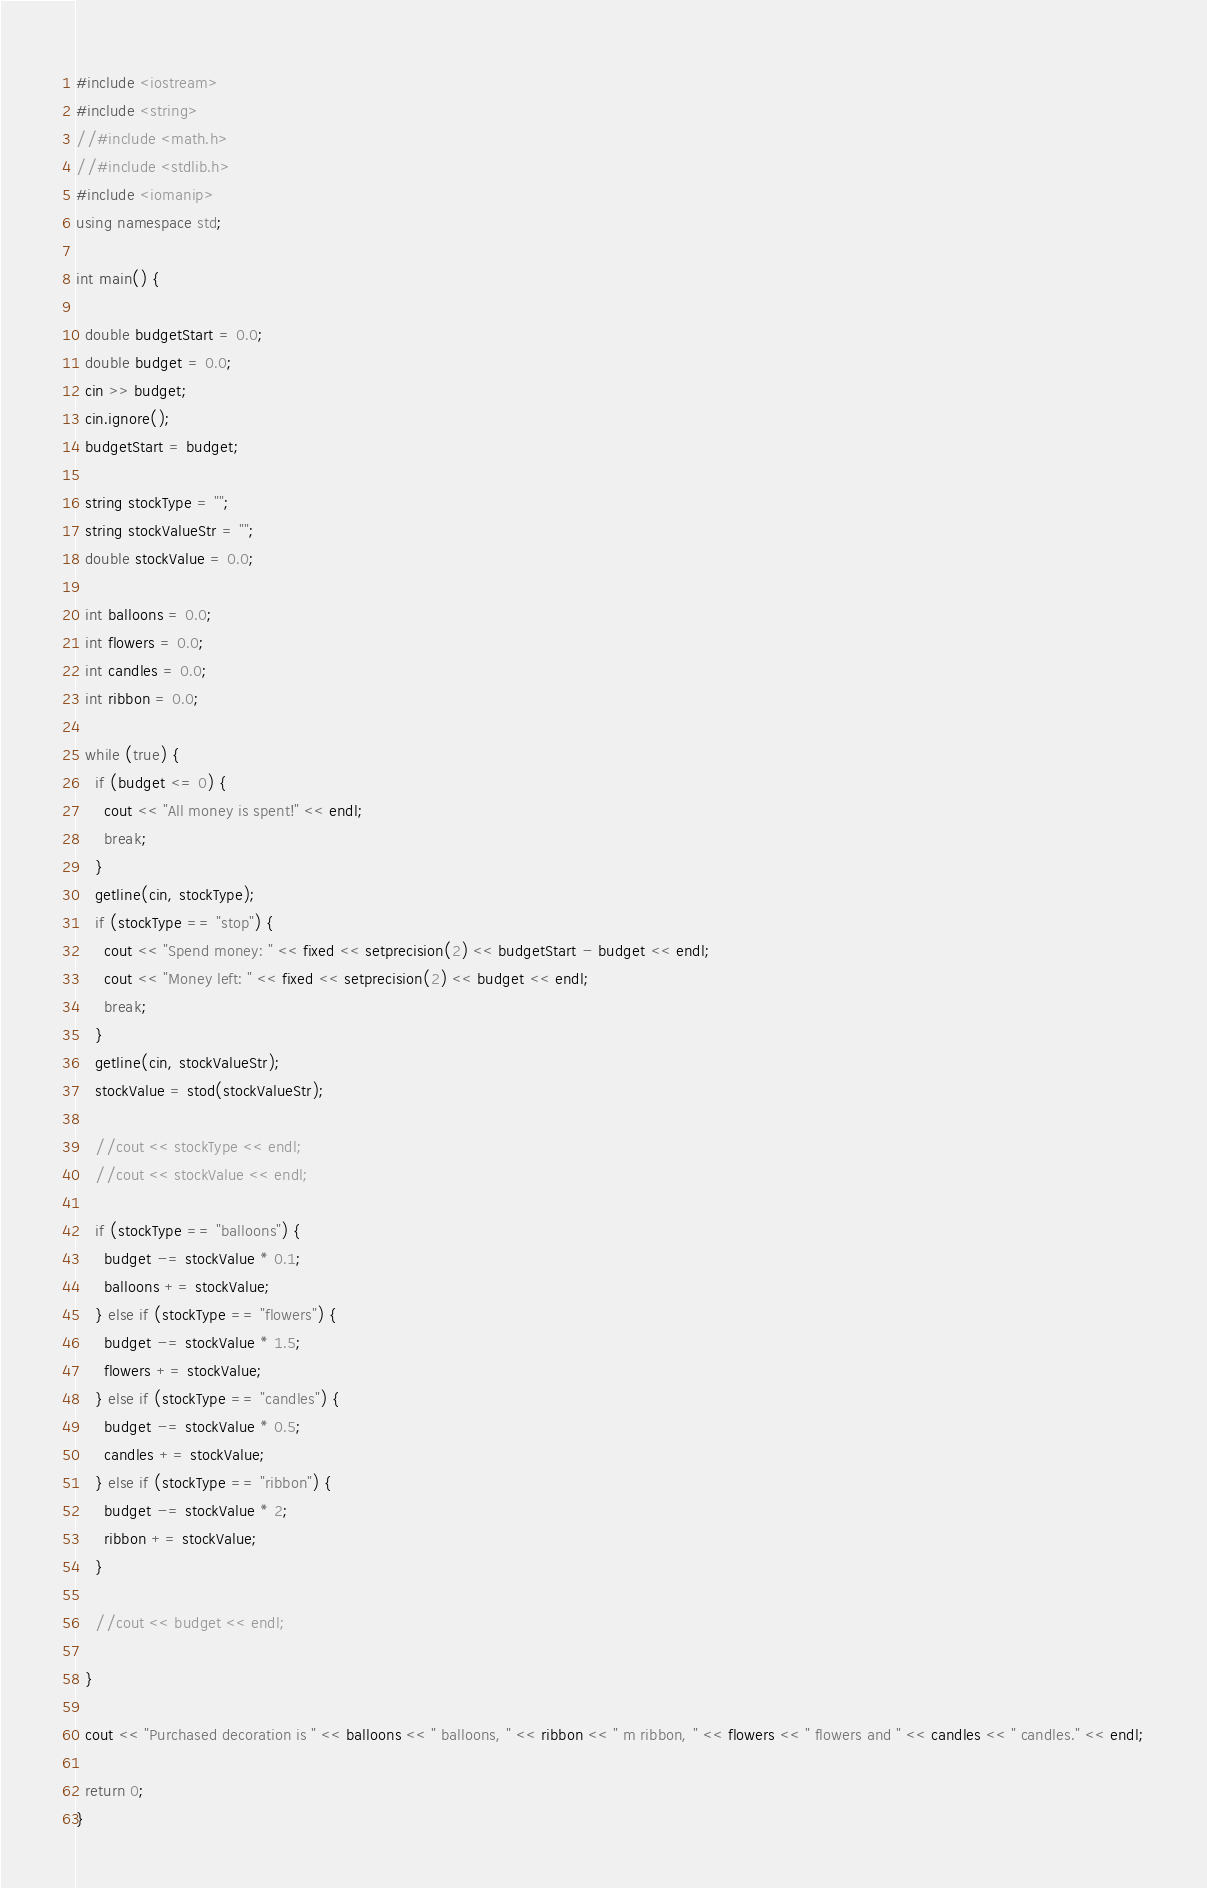<code> <loc_0><loc_0><loc_500><loc_500><_C++_>#include <iostream>
#include <string>
//#include <math.h> 
//#include <stdlib.h> 
#include <iomanip>
using namespace std;

int main() {

  double budgetStart = 0.0;
  double budget = 0.0;
  cin >> budget;
  cin.ignore();
  budgetStart = budget;

  string stockType = "";
  string stockValueStr = "";
  double stockValue = 0.0;

  int balloons = 0.0;
  int flowers = 0.0;
  int candles = 0.0;
  int ribbon = 0.0;

  while (true) {
    if (budget <= 0) { 
      cout << "All money is spent!" << endl;
      break; 
    }
    getline(cin, stockType);
    if (stockType == "stop") { 
      cout << "Spend money: " << fixed << setprecision(2) << budgetStart - budget << endl;
      cout << "Money left: " << fixed << setprecision(2) << budget << endl;
      break; 
    }
    getline(cin, stockValueStr);
    stockValue = stod(stockValueStr);

    //cout << stockType << endl;
    //cout << stockValue << endl;

    if (stockType == "balloons") {
      budget -= stockValue * 0.1;
      balloons += stockValue;
    } else if (stockType == "flowers") {
      budget -= stockValue * 1.5;
      flowers += stockValue;    
    } else if (stockType == "candles") {
      budget -= stockValue * 0.5;
      candles += stockValue;       
    } else if (stockType == "ribbon") {
      budget -= stockValue * 2;
      ribbon += stockValue;    
    }

    //cout << budget << endl;

  }

  cout << "Purchased decoration is " << balloons << " balloons, " << ribbon << " m ribbon, " << flowers << " flowers and " << candles << " candles." << endl;

  return 0;
}</code> 